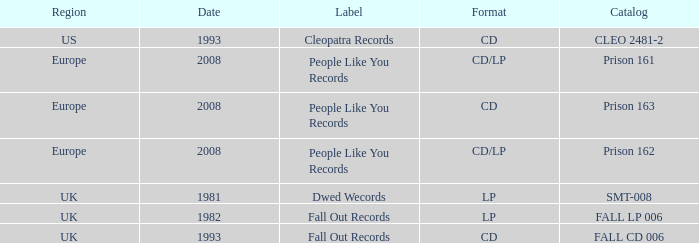Which Format has a Date of 1993, and a Catalog of cleo 2481-2? CD. 